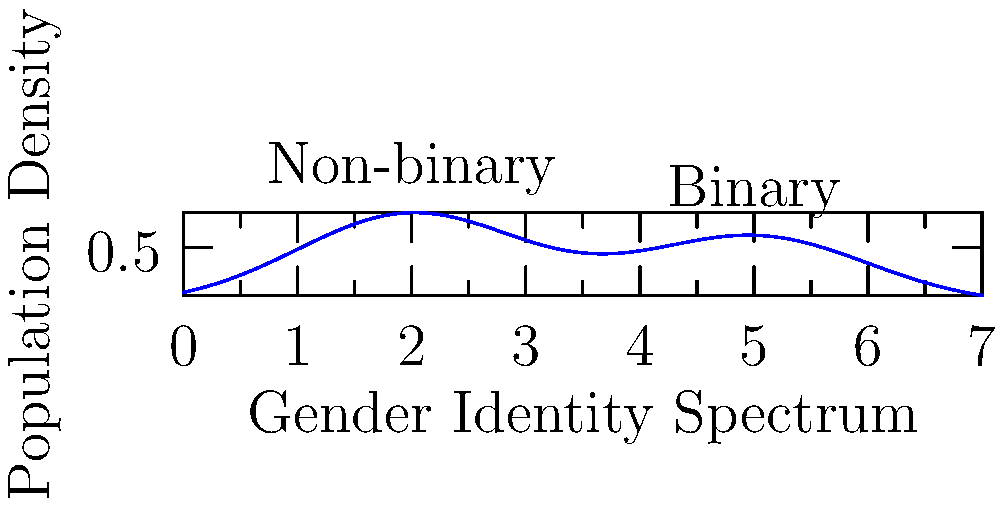The graph above represents the distribution of gender identities in a population, with the x-axis representing a spectrum from non-binary to binary identities. If the total population is 10,000, calculate the approximate number of individuals who fall between 3 and 4 on the gender identity spectrum. Use the trapezoidal rule with 4 subintervals to estimate the area under the curve between x = 3 and x = 4. To solve this problem, we'll follow these steps:

1) The trapezoidal rule for 4 subintervals is given by:

   $$\int_{a}^{b} f(x) dx \approx \frac{h}{2}[f(x_0) + 2f(x_1) + 2f(x_2) + 2f(x_3) + f(x_4)]$$

   where $h = \frac{b-a}{n}$, $n$ is the number of subintervals, and $x_i = a + ih$.

2) In our case, $a = 3$, $b = 4$, and $n = 4$. So, $h = \frac{4-3}{4} = 0.25$.

3) We need to calculate $f(x)$ at $x = 3, 3.25, 3.5, 3.75,$ and $4$.

4) From the graph, we can approximate these values:
   $f(3) \approx 0.62$
   $f(3.25) \approx 0.58$
   $f(3.5) \approx 0.55$
   $f(3.75) \approx 0.53$
   $f(4) \approx 0.52$

5) Applying the trapezoidal rule:

   $$\int_{3}^{4} f(x) dx \approx \frac{0.25}{2}[0.62 + 2(0.58) + 2(0.55) + 2(0.53) + 0.52]$$
   $$= 0.125[0.62 + 1.16 + 1.1 + 1.06 + 0.52]$$
   $$= 0.125[4.46] = 0.5575$$

6) This represents the area under the curve from 3 to 4, which is a proportion of the total population.

7) To get the number of individuals, we multiply by the total population:

   $0.5575 * 10,000 = 5,575$

Therefore, approximately 5,575 individuals fall between 3 and 4 on the gender identity spectrum.
Answer: 5,575 individuals 